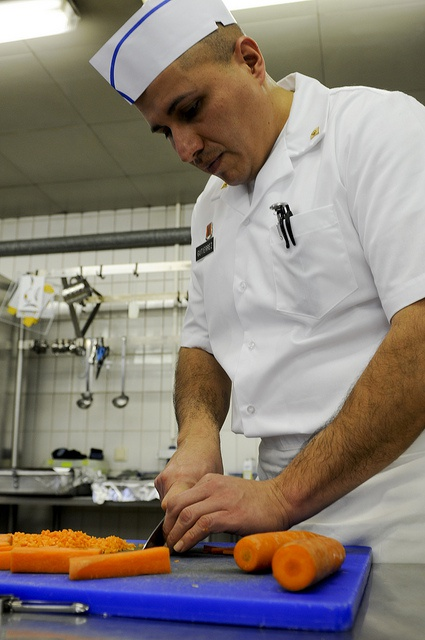Describe the objects in this image and their specific colors. I can see people in gray, darkgray, lightgray, and maroon tones, carrot in gray, red, and maroon tones, carrot in gray, red, maroon, and orange tones, carrot in gray, orange, and red tones, and carrot in gray, maroon, red, and brown tones in this image. 